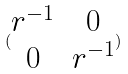Convert formula to latex. <formula><loc_0><loc_0><loc_500><loc_500>( \begin{matrix} r ^ { - 1 } & 0 \\ 0 & r ^ { - 1 } \end{matrix} )</formula> 